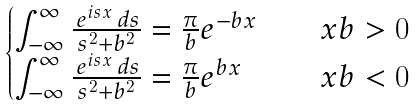<formula> <loc_0><loc_0><loc_500><loc_500>\begin{cases} \int _ { - \infty } ^ { \infty } \frac { \, e ^ { i s x } \, d s } { s ^ { 2 } + b ^ { 2 } } = \frac { \pi } { b } e ^ { - b x } & \quad x b > 0 \\ \int _ { - \infty } ^ { \infty } \frac { \, e ^ { i s x } \, d s } { s ^ { 2 } + b ^ { 2 } } = \frac { \pi } { b } e ^ { b x } & \quad x b < 0 \\ \end{cases}</formula> 